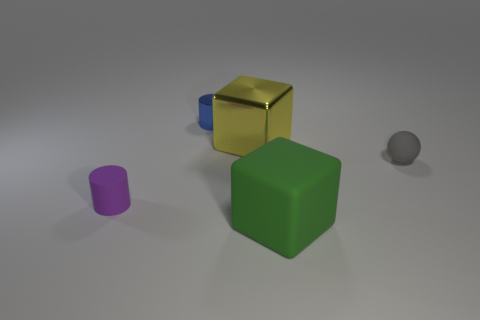What color is the large cube that is made of the same material as the blue cylinder?
Keep it short and to the point. Yellow. What is the material of the tiny blue thing that is the same shape as the small purple object?
Make the answer very short. Metal. What is the shape of the small purple rubber object?
Your answer should be very brief. Cylinder. The small thing that is in front of the shiny block and right of the matte cylinder is made of what material?
Offer a terse response. Rubber. There is a green thing that is the same material as the tiny purple cylinder; what is its shape?
Provide a succinct answer. Cube. The cylinder that is made of the same material as the big yellow cube is what size?
Ensure brevity in your answer.  Small. What shape is the tiny thing that is in front of the blue metallic cylinder and right of the purple thing?
Offer a terse response. Sphere. There is a cylinder that is in front of the small cylinder that is behind the gray thing; how big is it?
Give a very brief answer. Small. How many other things are there of the same color as the rubber block?
Give a very brief answer. 0. What is the large yellow thing made of?
Your response must be concise. Metal. 